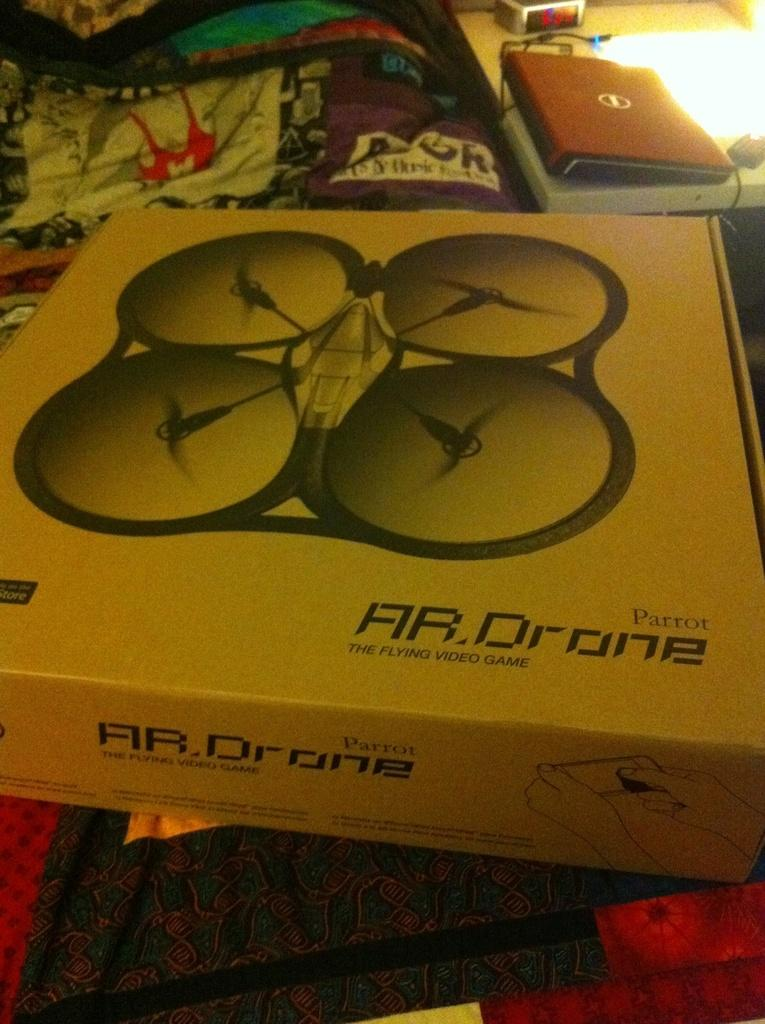What is on the bed in the foreground of the image? There is a box on the bed in the foreground. What other furniture can be seen in the image? There is a table in the image. What items are on the table? Books and wires are present on the table. Where is the image taken? The image is taken in a room. What type of curve can be seen on the goose in the image? There is no goose present in the image, and therefore no curve can be observed on a goose. Is the room in the image a prison cell? There is no indication in the image that the room is a prison cell. 